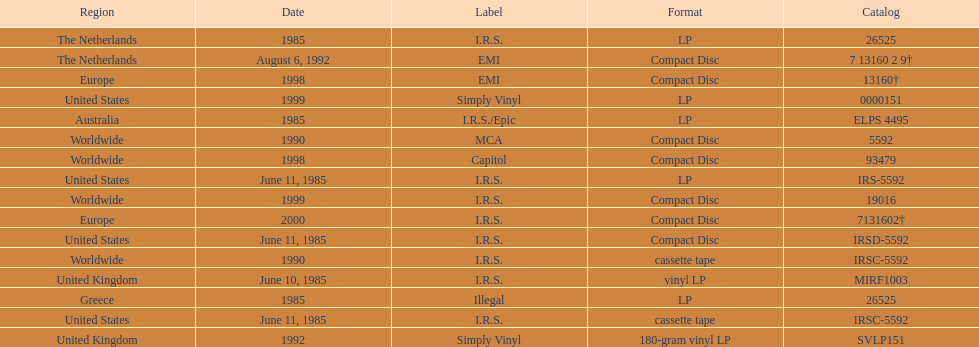Which is the only region with vinyl lp format? United Kingdom. 